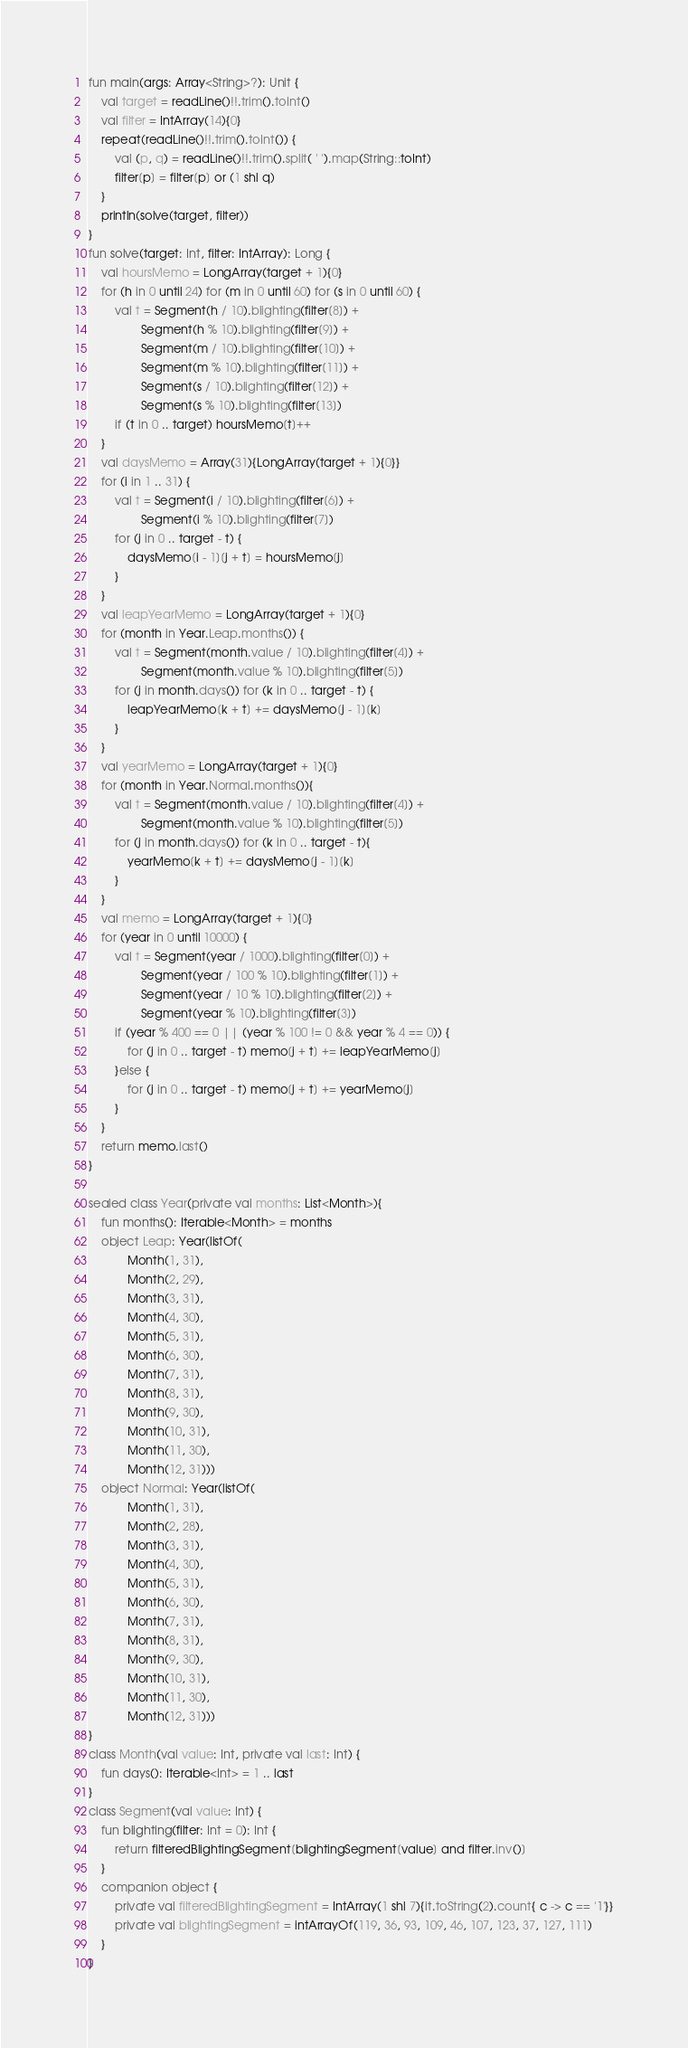Convert code to text. <code><loc_0><loc_0><loc_500><loc_500><_Kotlin_>fun main(args: Array<String>?): Unit {
    val target = readLine()!!.trim().toInt()
    val filter = IntArray(14){0}
    repeat(readLine()!!.trim().toInt()) {
        val (p, q) = readLine()!!.trim().split( ' ').map(String::toInt)
        filter[p] = filter[p] or (1 shl q)
    }
    println(solve(target, filter))
}
fun solve(target: Int, filter: IntArray): Long {
    val hoursMemo = LongArray(target + 1){0}
    for (h in 0 until 24) for (m in 0 until 60) for (s in 0 until 60) {
        val t = Segment(h / 10).blighting(filter[8]) +
                Segment(h % 10).blighting(filter[9]) +
                Segment(m / 10).blighting(filter[10]) +
                Segment(m % 10).blighting(filter[11]) +
                Segment(s / 10).blighting(filter[12]) +
                Segment(s % 10).blighting(filter[13])
        if (t in 0 .. target) hoursMemo[t]++
    }
    val daysMemo = Array(31){LongArray(target + 1){0}}
    for (i in 1 .. 31) {
        val t = Segment(i / 10).blighting(filter[6]) +
                Segment(i % 10).blighting(filter[7])
        for (j in 0 .. target - t) {
            daysMemo[i - 1][j + t] = hoursMemo[j]
        }
    }
    val leapYearMemo = LongArray(target + 1){0}
    for (month in Year.Leap.months()) {
        val t = Segment(month.value / 10).blighting(filter[4]) +
                Segment(month.value % 10).blighting(filter[5])
        for (j in month.days()) for (k in 0 .. target - t) {
            leapYearMemo[k + t] += daysMemo[j - 1][k]
        }
    }
    val yearMemo = LongArray(target + 1){0}
    for (month in Year.Normal.months()){
        val t = Segment(month.value / 10).blighting(filter[4]) +
                Segment(month.value % 10).blighting(filter[5])
        for (j in month.days()) for (k in 0 .. target - t){
            yearMemo[k + t] += daysMemo[j - 1][k]
        }
    }
    val memo = LongArray(target + 1){0}
    for (year in 0 until 10000) {
        val t = Segment(year / 1000).blighting(filter[0]) +
                Segment(year / 100 % 10).blighting(filter[1]) +
                Segment(year / 10 % 10).blighting(filter[2]) +
                Segment(year % 10).blighting(filter[3])
        if (year % 400 == 0 || (year % 100 != 0 && year % 4 == 0)) {
            for (j in 0 .. target - t) memo[j + t] += leapYearMemo[j]
        }else {
            for (j in 0 .. target - t) memo[j + t] += yearMemo[j]
        }
    }
    return memo.last()
}

sealed class Year(private val months: List<Month>){
    fun months(): Iterable<Month> = months
    object Leap: Year(listOf(
            Month(1, 31),
            Month(2, 29),
            Month(3, 31),
            Month(4, 30),
            Month(5, 31),
            Month(6, 30),
            Month(7, 31),
            Month(8, 31),
            Month(9, 30),
            Month(10, 31),
            Month(11, 30),
            Month(12, 31)))
    object Normal: Year(listOf(
            Month(1, 31),
            Month(2, 28),
            Month(3, 31),
            Month(4, 30),
            Month(5, 31),
            Month(6, 30),
            Month(7, 31),
            Month(8, 31),
            Month(9, 30),
            Month(10, 31),
            Month(11, 30),
            Month(12, 31)))
}
class Month(val value: Int, private val last: Int) {
    fun days(): Iterable<Int> = 1 .. last
}
class Segment(val value: Int) {
    fun blighting(filter: Int = 0): Int {
        return filteredBlightingSegment[blightingSegment[value] and filter.inv()]
    }
    companion object {
        private val filteredBlightingSegment = IntArray(1 shl 7){it.toString(2).count{ c -> c == '1'}}
        private val blightingSegment = intArrayOf(119, 36, 93, 109, 46, 107, 123, 37, 127, 111)
    }
}
</code> 